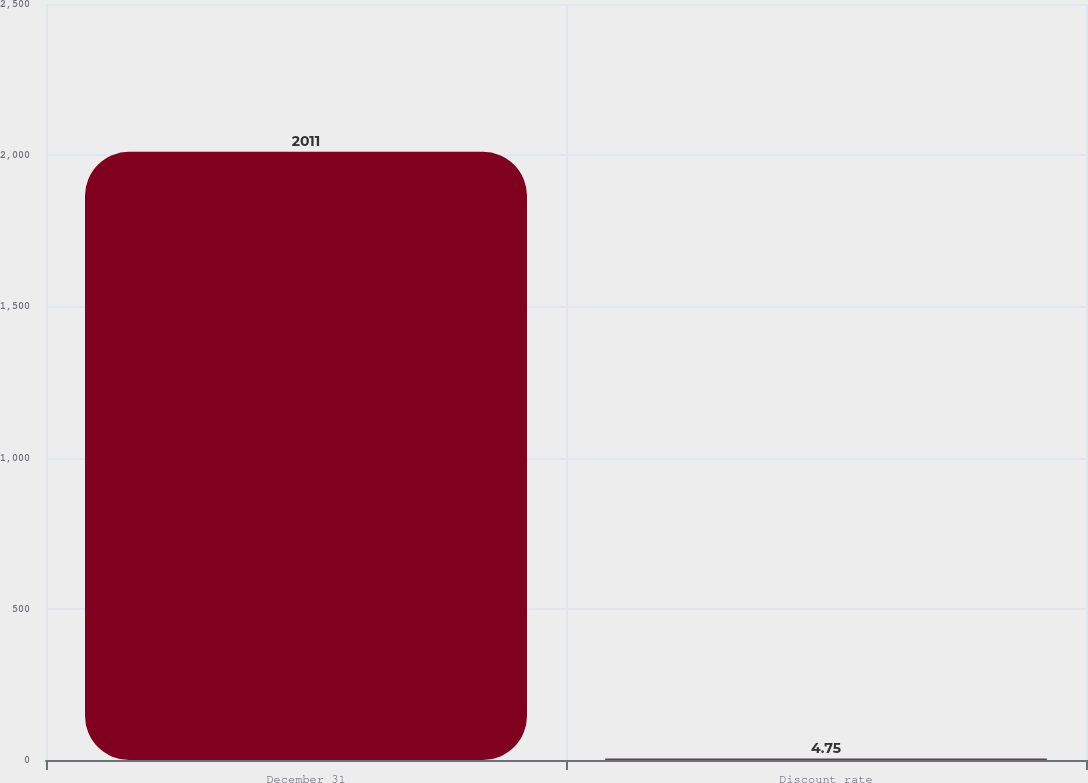Convert chart. <chart><loc_0><loc_0><loc_500><loc_500><bar_chart><fcel>December 31<fcel>Discount rate<nl><fcel>2011<fcel>4.75<nl></chart> 